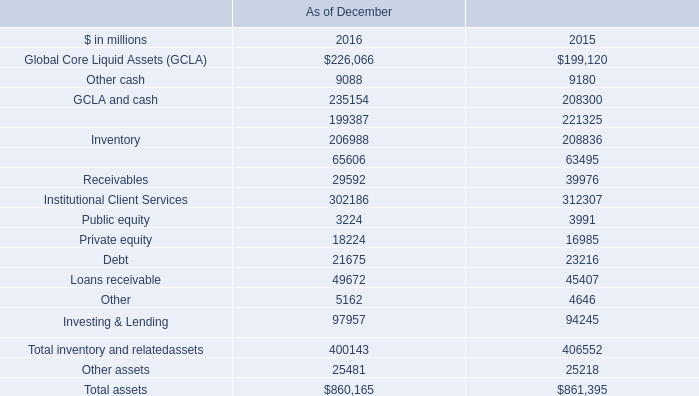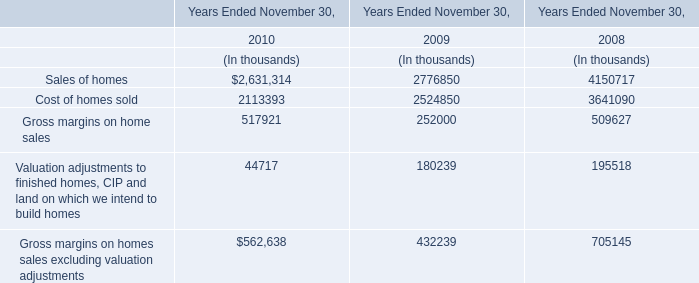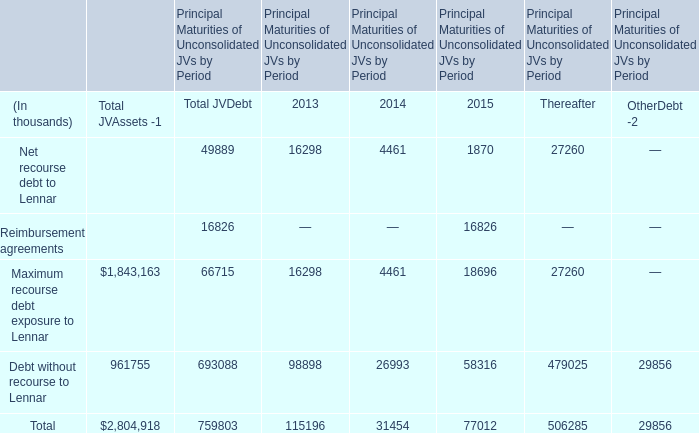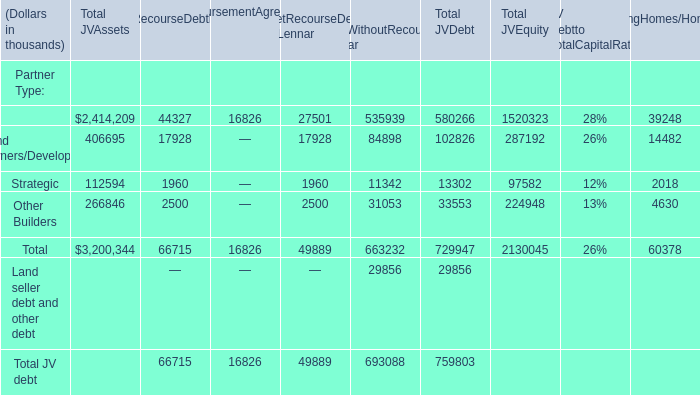What is the proportion of all ReimbursementAgreements that are greater than 0 to the total amount of ReimbursementAgreements, in Partner Type? 
Computations: (16826 / 16826)
Answer: 1.0. 